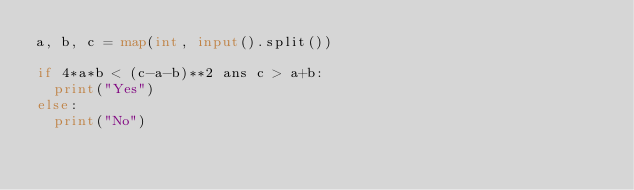<code> <loc_0><loc_0><loc_500><loc_500><_Python_>a, b, c = map(int, input().split())

if 4*a*b < (c-a-b)**2 ans c > a+b:
  print("Yes")
else:
  print("No")</code> 